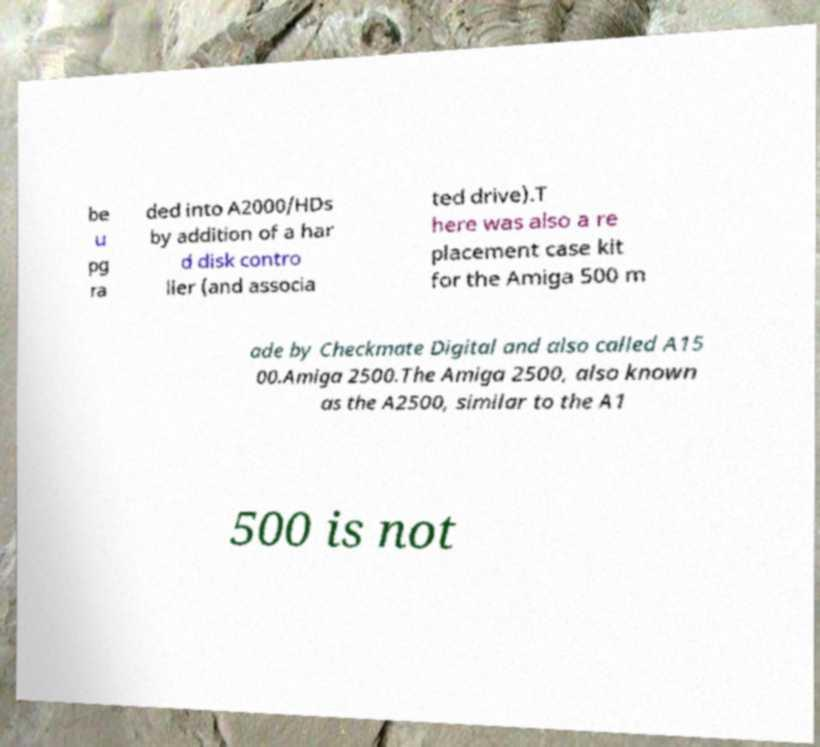Can you read and provide the text displayed in the image?This photo seems to have some interesting text. Can you extract and type it out for me? be u pg ra ded into A2000/HDs by addition of a har d disk contro ller (and associa ted drive).T here was also a re placement case kit for the Amiga 500 m ade by Checkmate Digital and also called A15 00.Amiga 2500.The Amiga 2500, also known as the A2500, similar to the A1 500 is not 